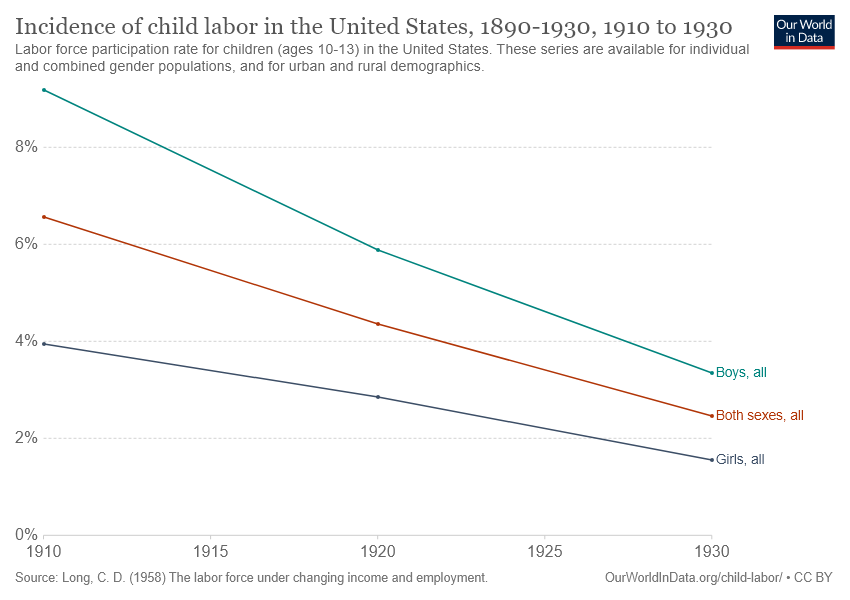Identify some key points in this picture. The gap between the average IQ scores of girls and boys becomes largest in the year 1910. The green line represents all boys. 